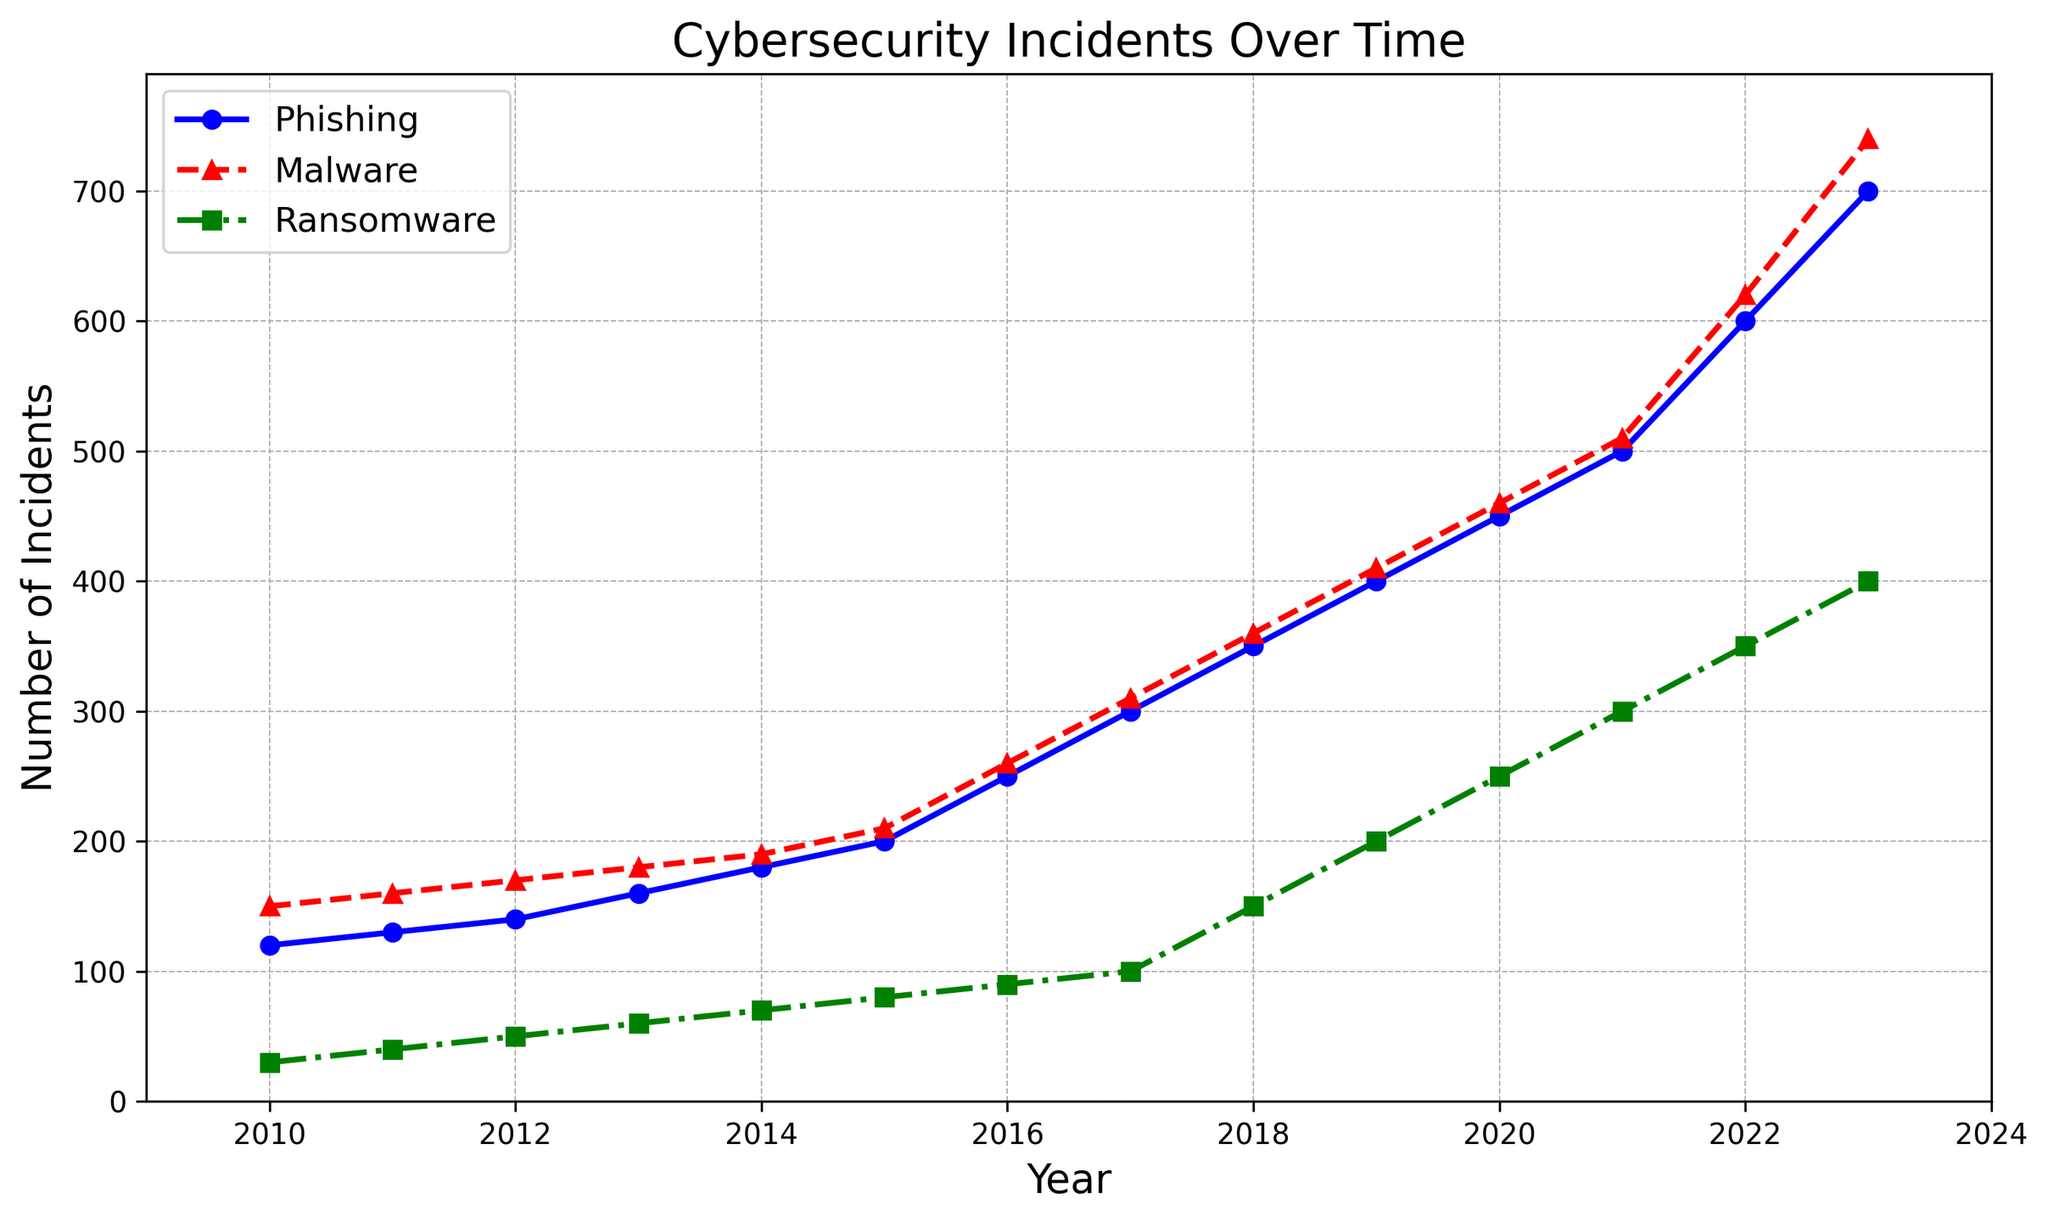What's the overall trend for phishing incidents from 2010 to 2023? The line for phishing incidents, represented in blue, shows a clear upward trend from 2010 to 2023. Each year, the number of phishing incidents increases steadily from 120 in 2010 to 700 in 2023.
Answer: Upward trend Which year did ransomware incidents see their largest increase compared to the previous year? By comparing the number of ransomware incidents year-over-year, 2018 saw the largest increase, going from 100 in 2017 to 150 in 2018, an increase of 50 incidents.
Answer: 2018 In which year did malware incidents reach 300? From the line representing malware incidents, shown in red with triangle markers, malware incidents reached 300 in the year 2017.
Answer: 2017 How many more phishing incidents were there in 2023 compared to 2010? In 2010, there were 120 phishing incidents, and in 2023, there were 700. The difference is 700 - 120 = 580.
Answer: 580 Which type of threat shows the most rapid growth rate over the given period? By visually inspecting the slopes of the lines, ransomware incidents (green, square markers) show the most rapid growth rate, especially in the latter years from 2018 onward.
Answer: Ransomware Compare the number of incidents for all three threats in 2020. Which threat had the highest number? In 2020, phishing had 450 incidents, malware had 460 incidents, and ransomware had 250 incidents. Hence, malware had the highest number of incidents in 2020.
Answer: Malware On average, how many malware incidents occurred annually from 2010 to 2023? Summing all the malware incidents from 2010 to 2023 yields 7100 incidents. Dividing by the number of years (2023-2010+1 = 14), the average is 7100 / 14 ≈ 507 incidents per year.
Answer: ~507 In which year did the number of phishing incidents surpass the number of malware incidents for the first time? Comparing the two lines, phishing incidents surpass malware incidents in 2022, where phishing has 600 incidents and malware has 620 incidents. In 2023, phishing clearly has more incidents, indicating the first surpass happened in 2023.
Answer: 2023 What is the median number of ransomware incidents from 2010 to 2023? Listing the ransomware incidents values in ascending order: 30, 40, 50, 60, 70, 80, 90, 100, 150, 200, 250, 300, 350, 400, the middle values are 100 and 150, so the median is (100 + 150) / 2 = 125.
Answer: 125 